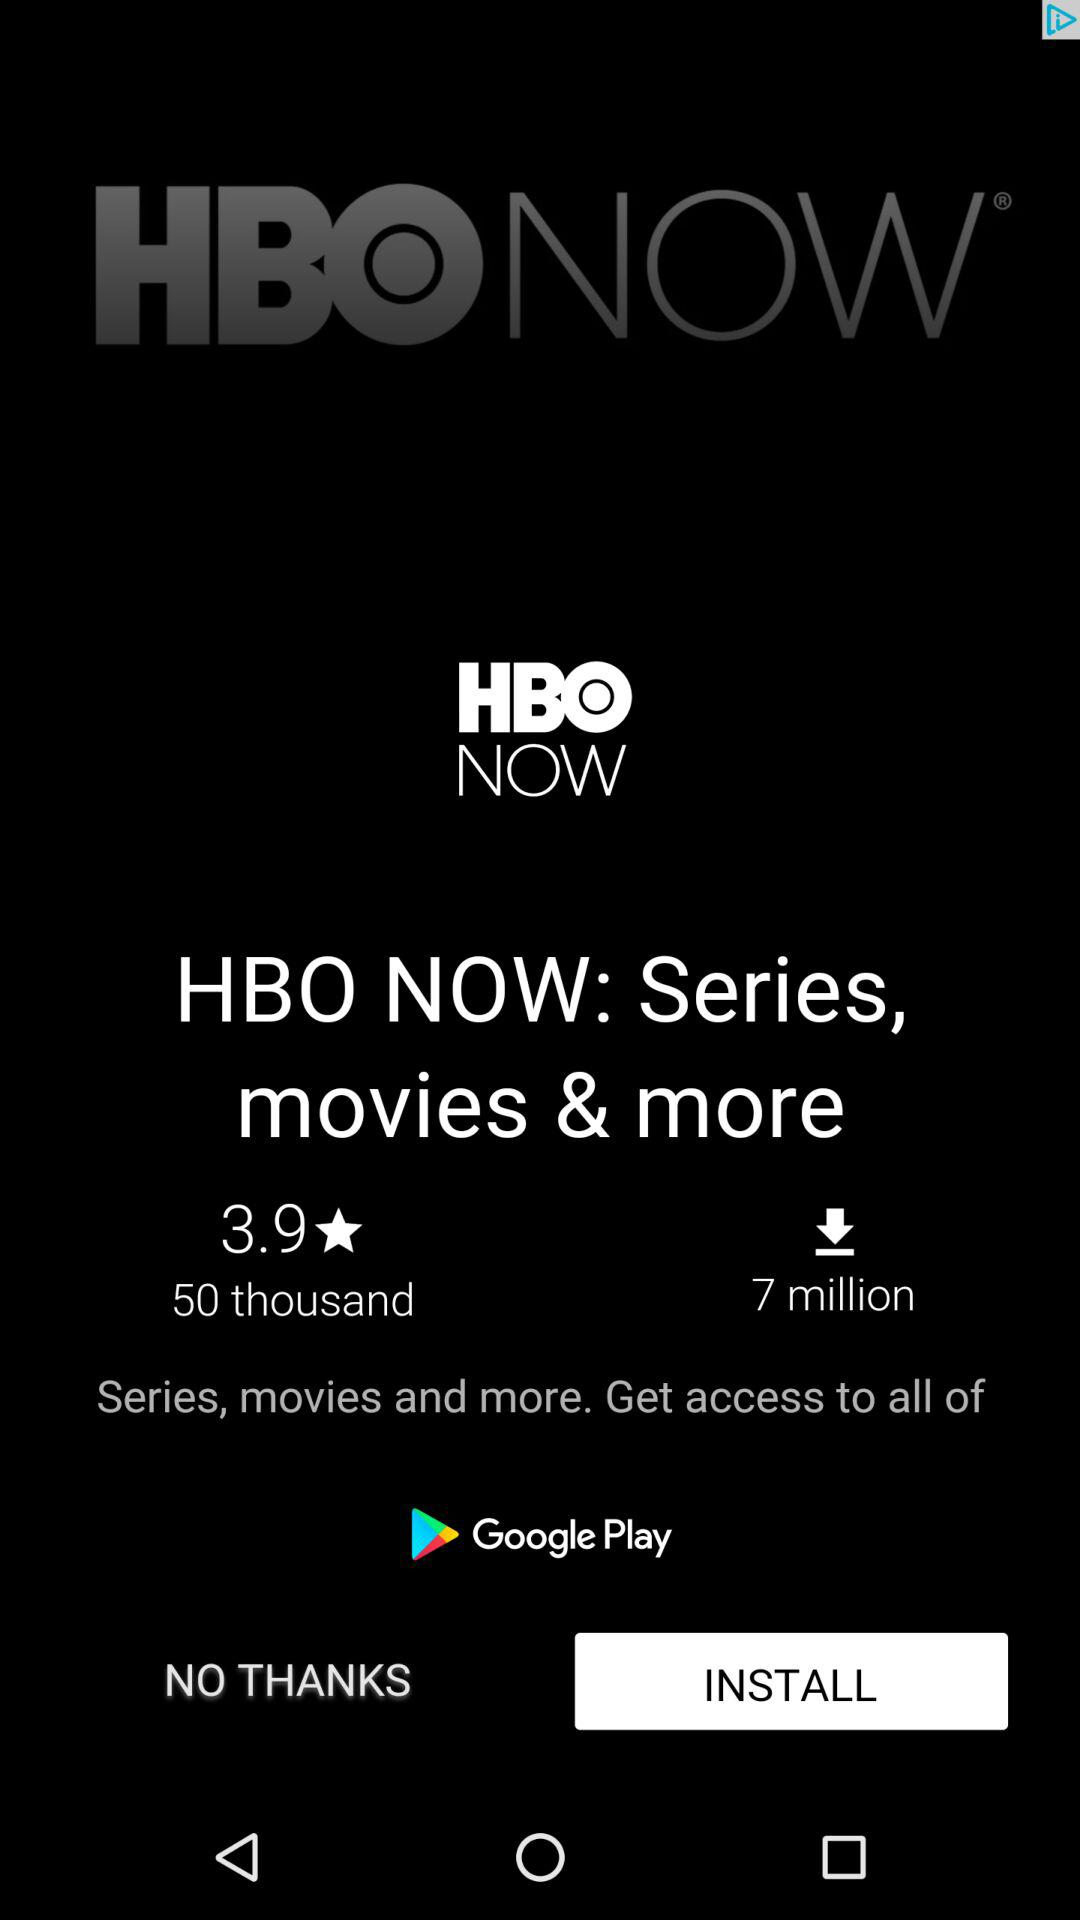How many more downloads does HBO NOW have than ratings?
Answer the question using a single word or phrase. 6950000 